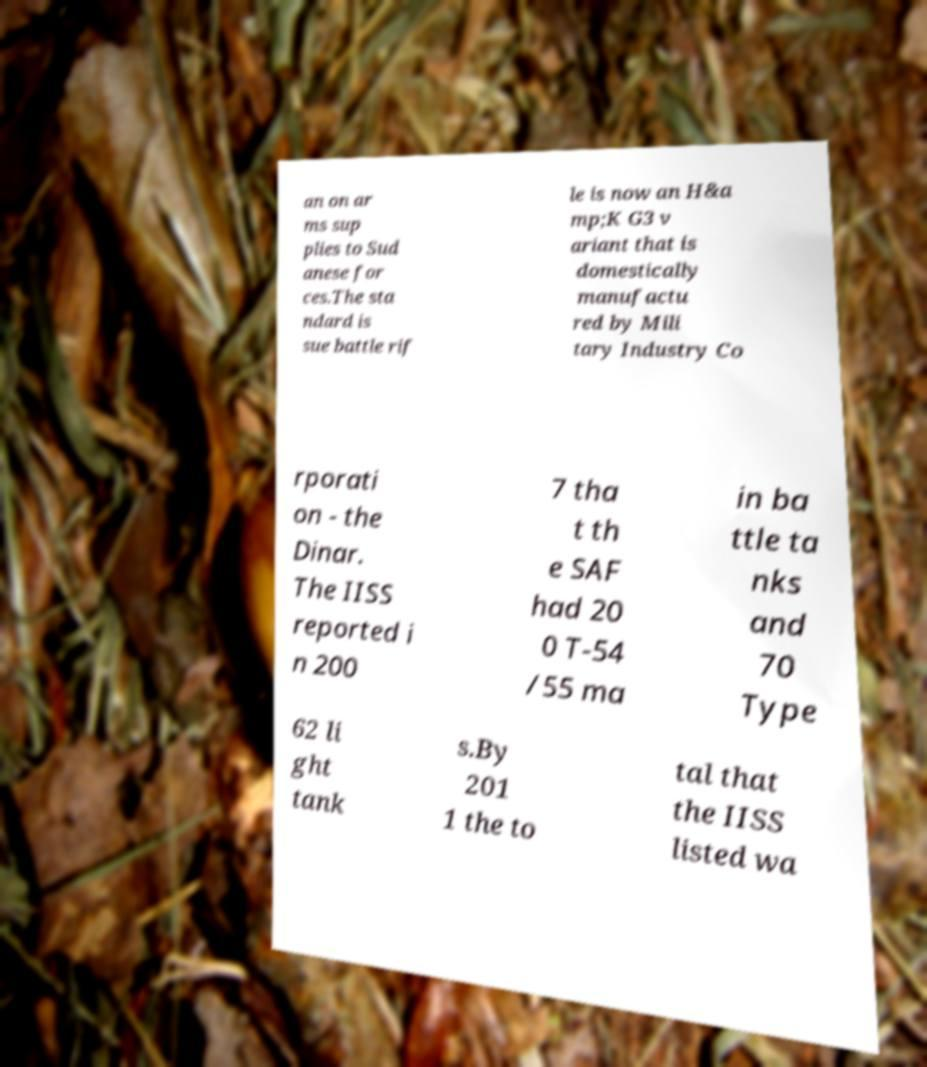Please identify and transcribe the text found in this image. an on ar ms sup plies to Sud anese for ces.The sta ndard is sue battle rif le is now an H&a mp;K G3 v ariant that is domestically manufactu red by Mili tary Industry Co rporati on - the Dinar. The IISS reported i n 200 7 tha t th e SAF had 20 0 T-54 /55 ma in ba ttle ta nks and 70 Type 62 li ght tank s.By 201 1 the to tal that the IISS listed wa 